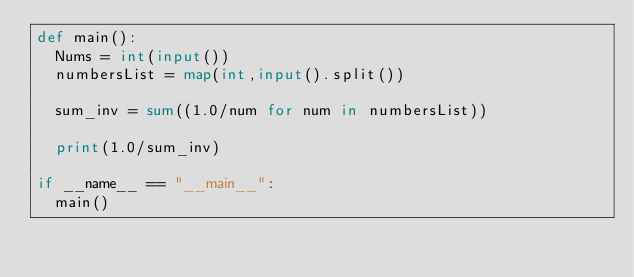<code> <loc_0><loc_0><loc_500><loc_500><_Python_>def main():
  Nums = int(input())
  numbersList = map(int,input().split())
  
  sum_inv = sum((1.0/num for num in numbersList))

  print(1.0/sum_inv)

if __name__ == "__main__":
  main()



</code> 